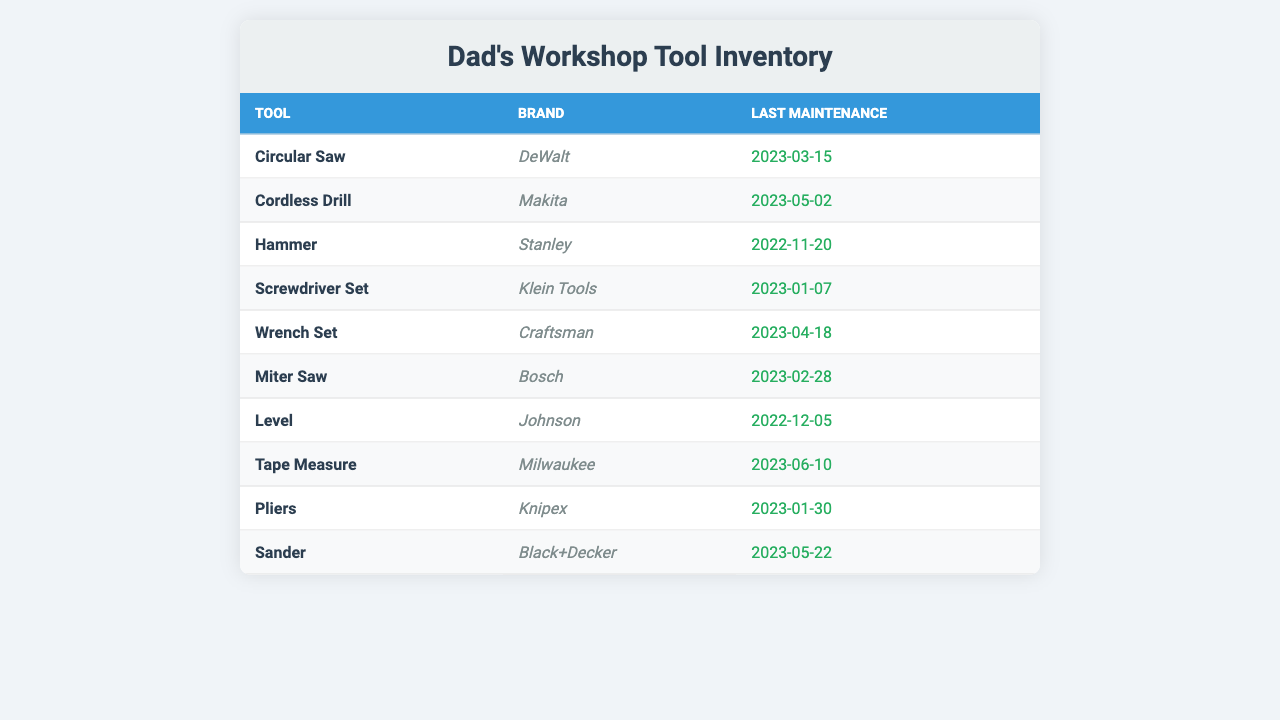What is the brand of the Circular Saw? The table shows a list of tools along with their brands. The entry for the Circular Saw indicates that the brand is DeWalt.
Answer: DeWalt When was the last maintenance for the Cordless Drill? Referring to the entry for the Cordless Drill, the last maintenance date is noted as May 2, 2023.
Answer: May 2, 2023 How many tools have had maintenance in 2023? By counting the entries with last maintenance dates in 2023, we find the tools: Circular Saw, Cordless Drill, Screwdriver Set, Wrench Set, Miter Saw, Pliers, Sander, and Tape Measure, which totals 8 tools.
Answer: 8 Is the Hammer maintained more recently than the Wrench Set? The Hammer's last maintenance was on November 20, 2022, while the Wrench Set's was on April 18, 2023. Since April 18 is after November 20, the statement is true.
Answer: Yes What tool was last maintained before the Screwdriver Set? The Screwdriver Set had its maintenance on January 7, 2023. Looking at the dates, the Pliers were maintained on January 30, 2023, which is after the Screwdriver Set; therefore, we check for December 2022, where the last maintenance prior to that was for the Level on December 5, 2022.
Answer: Level How many tools were maintained in the month of May? Checking the entries for the month of May, we find the Cordless Drill (May 2, 2023) and the Sander (May 22, 2023) were both maintained that month, totaling 2 tools.
Answer: 2 Which tool has not been maintained in 2023? By analyzing each tool's last maintenance date, the Hammer (November 20, 2022) and Level (December 5, 2022) were not maintained in 2023, while the others were.
Answer: Hammer, Level What is the average maintenance year of the tools? The tools have maintenance dates from 2022 and 2023. Counting the tools, we have 2 tools from 2022 and 8 from 2023. The average year would be calculated using the formula: [(2 tools in 2022 * 2022) + (8 tools in 2023 * 2023)] / 10 tools = (4044 + 16240) / 10 = 2068.4. This indicates that the average maintenance is weighted towards 2023.
Answer: 2023 Are there more tools by DeWalt or by Makita? The table shows one tool from DeWalt (Circular Saw) and one tool from Makita (Cordless Drill). Thus, there is an equal count of tools from both brands.
Answer: Equal Which brand of tools has the most recent maintenance date listed? The most recent maintenance date listed is June 10, 2023, for the Tape Measure, which is a Milwaukee brand. Therefore, Milwaukee has the most recent maintenance.
Answer: Milwaukee 